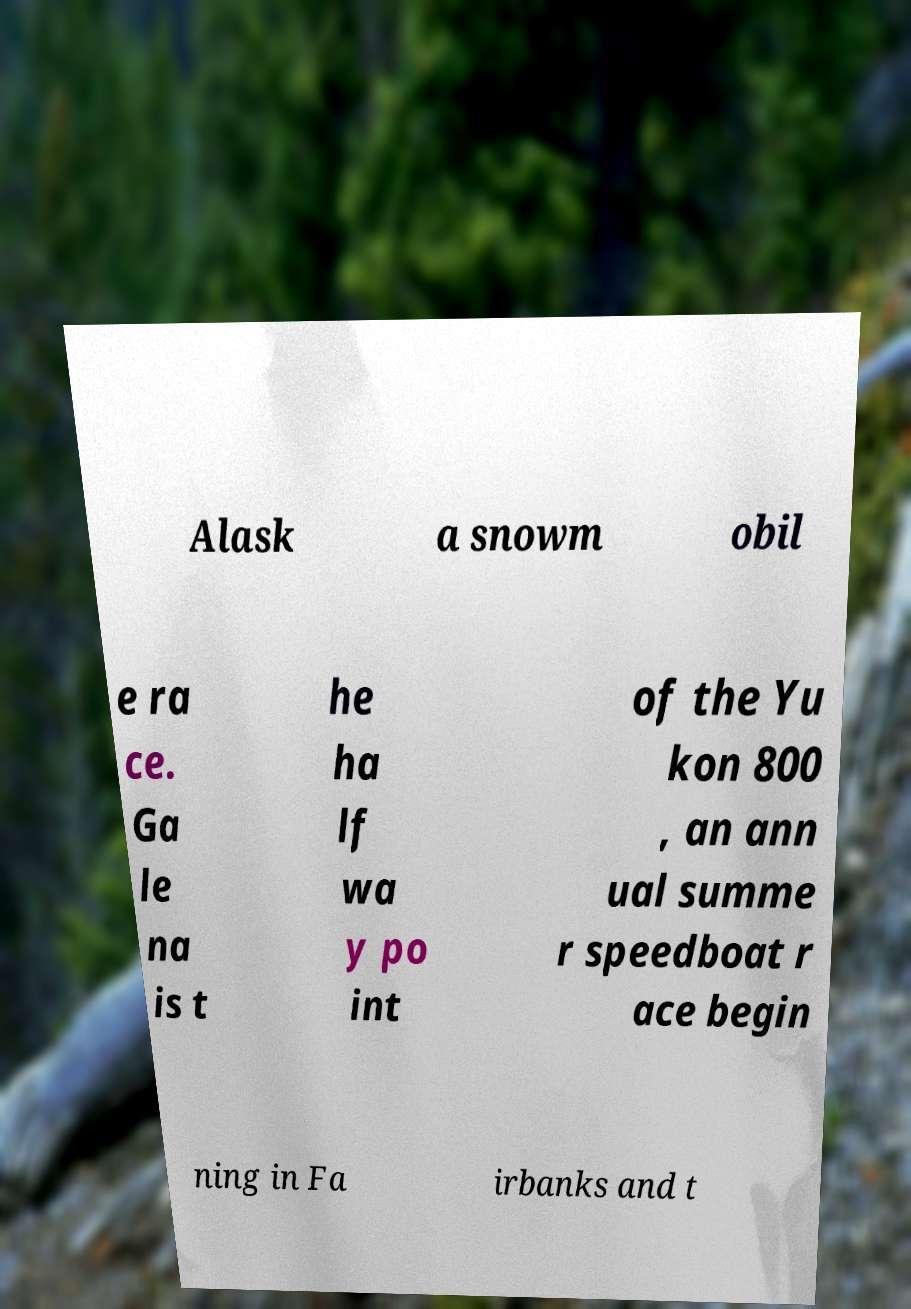Can you read and provide the text displayed in the image?This photo seems to have some interesting text. Can you extract and type it out for me? Alask a snowm obil e ra ce. Ga le na is t he ha lf wa y po int of the Yu kon 800 , an ann ual summe r speedboat r ace begin ning in Fa irbanks and t 